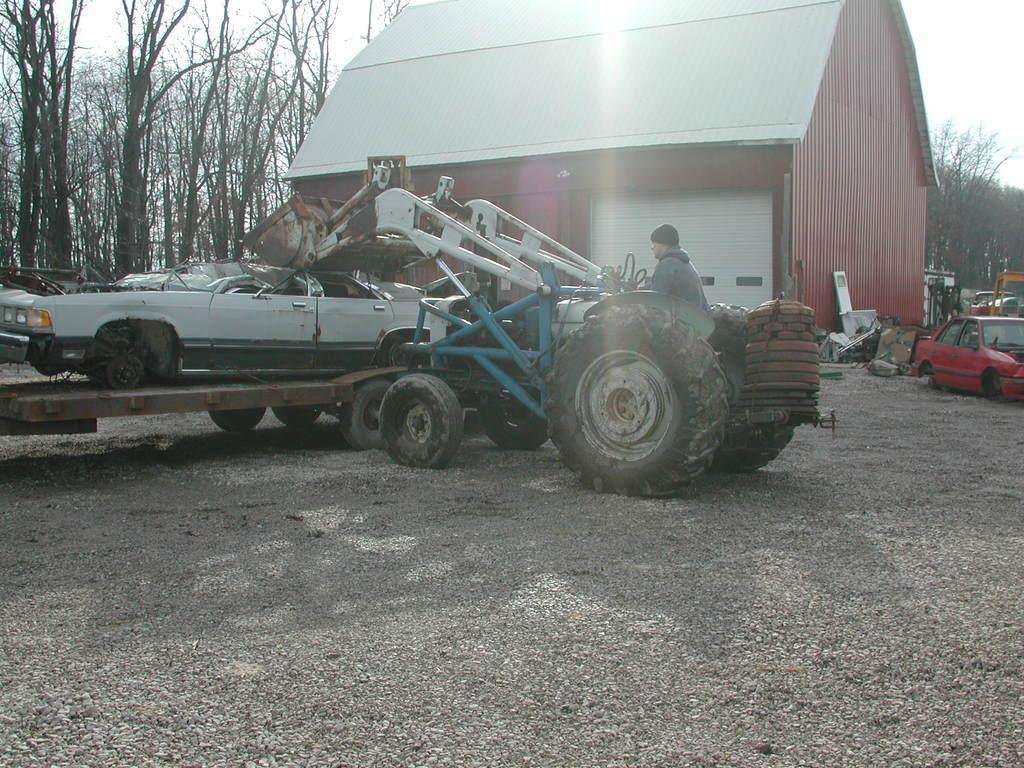Please provide a concise description of this image. In this picture there are vehicles and there is a person sitting on the tractor, there is a house and there are trees, at the top there is sky. 